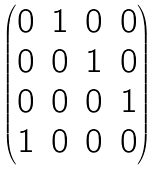Convert formula to latex. <formula><loc_0><loc_0><loc_500><loc_500>\begin{pmatrix} 0 & 1 & 0 & 0 \\ 0 & 0 & 1 & 0 \\ 0 & 0 & 0 & 1 \\ 1 & 0 & 0 & 0 \end{pmatrix}</formula> 